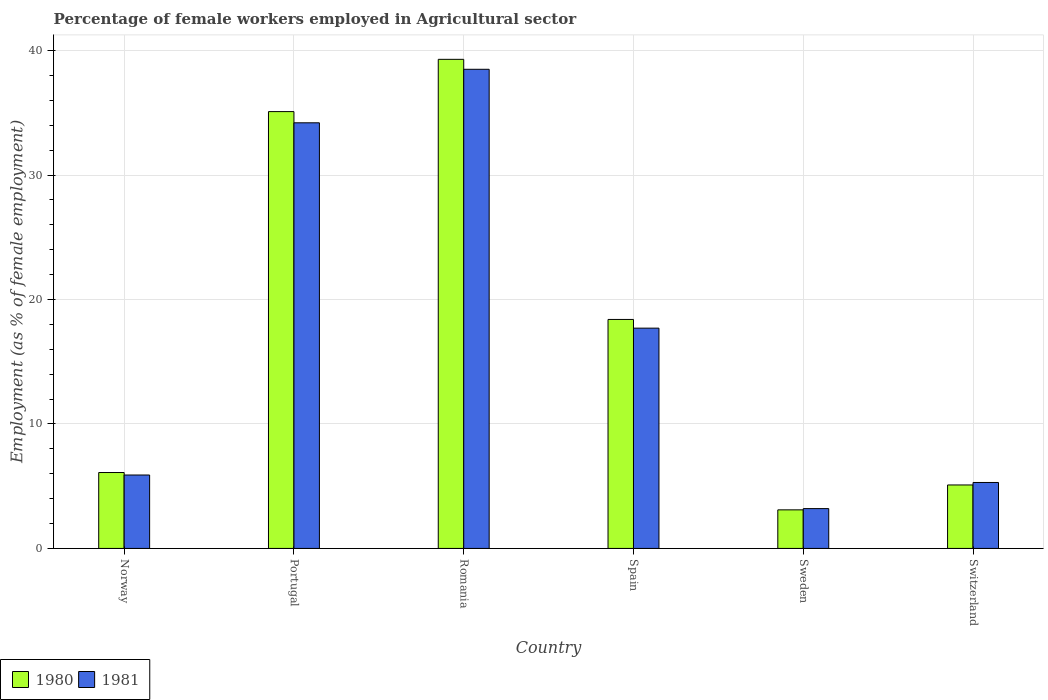How many groups of bars are there?
Make the answer very short. 6. How many bars are there on the 5th tick from the left?
Your response must be concise. 2. How many bars are there on the 6th tick from the right?
Give a very brief answer. 2. What is the label of the 5th group of bars from the left?
Offer a very short reply. Sweden. What is the percentage of females employed in Agricultural sector in 1981 in Spain?
Offer a very short reply. 17.7. Across all countries, what is the maximum percentage of females employed in Agricultural sector in 1981?
Keep it short and to the point. 38.5. Across all countries, what is the minimum percentage of females employed in Agricultural sector in 1980?
Offer a terse response. 3.1. In which country was the percentage of females employed in Agricultural sector in 1980 maximum?
Offer a terse response. Romania. What is the total percentage of females employed in Agricultural sector in 1980 in the graph?
Offer a very short reply. 107.1. What is the difference between the percentage of females employed in Agricultural sector in 1980 in Portugal and that in Sweden?
Keep it short and to the point. 32. What is the difference between the percentage of females employed in Agricultural sector in 1981 in Portugal and the percentage of females employed in Agricultural sector in 1980 in Romania?
Your answer should be very brief. -5.1. What is the average percentage of females employed in Agricultural sector in 1981 per country?
Offer a terse response. 17.47. What is the difference between the percentage of females employed in Agricultural sector of/in 1980 and percentage of females employed in Agricultural sector of/in 1981 in Romania?
Offer a very short reply. 0.8. In how many countries, is the percentage of females employed in Agricultural sector in 1980 greater than 24 %?
Your answer should be compact. 2. What is the ratio of the percentage of females employed in Agricultural sector in 1981 in Portugal to that in Switzerland?
Your response must be concise. 6.45. Is the percentage of females employed in Agricultural sector in 1981 in Romania less than that in Spain?
Your answer should be compact. No. Is the difference between the percentage of females employed in Agricultural sector in 1980 in Norway and Romania greater than the difference between the percentage of females employed in Agricultural sector in 1981 in Norway and Romania?
Ensure brevity in your answer.  No. What is the difference between the highest and the second highest percentage of females employed in Agricultural sector in 1980?
Offer a very short reply. -16.7. What is the difference between the highest and the lowest percentage of females employed in Agricultural sector in 1981?
Ensure brevity in your answer.  35.3. Is the sum of the percentage of females employed in Agricultural sector in 1981 in Portugal and Sweden greater than the maximum percentage of females employed in Agricultural sector in 1980 across all countries?
Provide a succinct answer. No. Are all the bars in the graph horizontal?
Your response must be concise. No. Are the values on the major ticks of Y-axis written in scientific E-notation?
Keep it short and to the point. No. Does the graph contain grids?
Give a very brief answer. Yes. Where does the legend appear in the graph?
Give a very brief answer. Bottom left. How many legend labels are there?
Make the answer very short. 2. What is the title of the graph?
Give a very brief answer. Percentage of female workers employed in Agricultural sector. Does "2004" appear as one of the legend labels in the graph?
Offer a very short reply. No. What is the label or title of the Y-axis?
Provide a succinct answer. Employment (as % of female employment). What is the Employment (as % of female employment) in 1980 in Norway?
Give a very brief answer. 6.1. What is the Employment (as % of female employment) in 1981 in Norway?
Provide a succinct answer. 5.9. What is the Employment (as % of female employment) of 1980 in Portugal?
Offer a terse response. 35.1. What is the Employment (as % of female employment) in 1981 in Portugal?
Your response must be concise. 34.2. What is the Employment (as % of female employment) in 1980 in Romania?
Ensure brevity in your answer.  39.3. What is the Employment (as % of female employment) in 1981 in Romania?
Give a very brief answer. 38.5. What is the Employment (as % of female employment) in 1980 in Spain?
Your answer should be very brief. 18.4. What is the Employment (as % of female employment) in 1981 in Spain?
Keep it short and to the point. 17.7. What is the Employment (as % of female employment) of 1980 in Sweden?
Offer a very short reply. 3.1. What is the Employment (as % of female employment) in 1981 in Sweden?
Your answer should be very brief. 3.2. What is the Employment (as % of female employment) of 1980 in Switzerland?
Your response must be concise. 5.1. What is the Employment (as % of female employment) of 1981 in Switzerland?
Keep it short and to the point. 5.3. Across all countries, what is the maximum Employment (as % of female employment) in 1980?
Your answer should be compact. 39.3. Across all countries, what is the maximum Employment (as % of female employment) in 1981?
Make the answer very short. 38.5. Across all countries, what is the minimum Employment (as % of female employment) of 1980?
Your answer should be compact. 3.1. Across all countries, what is the minimum Employment (as % of female employment) of 1981?
Your answer should be very brief. 3.2. What is the total Employment (as % of female employment) of 1980 in the graph?
Provide a short and direct response. 107.1. What is the total Employment (as % of female employment) of 1981 in the graph?
Your answer should be compact. 104.8. What is the difference between the Employment (as % of female employment) in 1980 in Norway and that in Portugal?
Your answer should be compact. -29. What is the difference between the Employment (as % of female employment) of 1981 in Norway and that in Portugal?
Your response must be concise. -28.3. What is the difference between the Employment (as % of female employment) of 1980 in Norway and that in Romania?
Offer a very short reply. -33.2. What is the difference between the Employment (as % of female employment) in 1981 in Norway and that in Romania?
Keep it short and to the point. -32.6. What is the difference between the Employment (as % of female employment) in 1980 in Norway and that in Sweden?
Make the answer very short. 3. What is the difference between the Employment (as % of female employment) of 1981 in Norway and that in Sweden?
Your response must be concise. 2.7. What is the difference between the Employment (as % of female employment) of 1981 in Norway and that in Switzerland?
Make the answer very short. 0.6. What is the difference between the Employment (as % of female employment) in 1981 in Portugal and that in Romania?
Ensure brevity in your answer.  -4.3. What is the difference between the Employment (as % of female employment) of 1980 in Portugal and that in Sweden?
Provide a succinct answer. 32. What is the difference between the Employment (as % of female employment) of 1981 in Portugal and that in Switzerland?
Your response must be concise. 28.9. What is the difference between the Employment (as % of female employment) of 1980 in Romania and that in Spain?
Make the answer very short. 20.9. What is the difference between the Employment (as % of female employment) in 1981 in Romania and that in Spain?
Provide a short and direct response. 20.8. What is the difference between the Employment (as % of female employment) of 1980 in Romania and that in Sweden?
Make the answer very short. 36.2. What is the difference between the Employment (as % of female employment) of 1981 in Romania and that in Sweden?
Provide a succinct answer. 35.3. What is the difference between the Employment (as % of female employment) of 1980 in Romania and that in Switzerland?
Provide a succinct answer. 34.2. What is the difference between the Employment (as % of female employment) of 1981 in Romania and that in Switzerland?
Ensure brevity in your answer.  33.2. What is the difference between the Employment (as % of female employment) in 1980 in Spain and that in Sweden?
Offer a very short reply. 15.3. What is the difference between the Employment (as % of female employment) in 1981 in Spain and that in Sweden?
Make the answer very short. 14.5. What is the difference between the Employment (as % of female employment) of 1981 in Sweden and that in Switzerland?
Your answer should be very brief. -2.1. What is the difference between the Employment (as % of female employment) of 1980 in Norway and the Employment (as % of female employment) of 1981 in Portugal?
Provide a succinct answer. -28.1. What is the difference between the Employment (as % of female employment) in 1980 in Norway and the Employment (as % of female employment) in 1981 in Romania?
Make the answer very short. -32.4. What is the difference between the Employment (as % of female employment) of 1980 in Norway and the Employment (as % of female employment) of 1981 in Spain?
Your response must be concise. -11.6. What is the difference between the Employment (as % of female employment) in 1980 in Norway and the Employment (as % of female employment) in 1981 in Sweden?
Your answer should be very brief. 2.9. What is the difference between the Employment (as % of female employment) in 1980 in Norway and the Employment (as % of female employment) in 1981 in Switzerland?
Provide a succinct answer. 0.8. What is the difference between the Employment (as % of female employment) in 1980 in Portugal and the Employment (as % of female employment) in 1981 in Sweden?
Ensure brevity in your answer.  31.9. What is the difference between the Employment (as % of female employment) in 1980 in Portugal and the Employment (as % of female employment) in 1981 in Switzerland?
Offer a terse response. 29.8. What is the difference between the Employment (as % of female employment) in 1980 in Romania and the Employment (as % of female employment) in 1981 in Spain?
Give a very brief answer. 21.6. What is the difference between the Employment (as % of female employment) in 1980 in Romania and the Employment (as % of female employment) in 1981 in Sweden?
Keep it short and to the point. 36.1. What is the difference between the Employment (as % of female employment) in 1980 in Sweden and the Employment (as % of female employment) in 1981 in Switzerland?
Provide a short and direct response. -2.2. What is the average Employment (as % of female employment) of 1980 per country?
Offer a terse response. 17.85. What is the average Employment (as % of female employment) in 1981 per country?
Keep it short and to the point. 17.47. What is the difference between the Employment (as % of female employment) in 1980 and Employment (as % of female employment) in 1981 in Norway?
Make the answer very short. 0.2. What is the difference between the Employment (as % of female employment) of 1980 and Employment (as % of female employment) of 1981 in Romania?
Give a very brief answer. 0.8. What is the difference between the Employment (as % of female employment) of 1980 and Employment (as % of female employment) of 1981 in Sweden?
Offer a very short reply. -0.1. What is the ratio of the Employment (as % of female employment) of 1980 in Norway to that in Portugal?
Keep it short and to the point. 0.17. What is the ratio of the Employment (as % of female employment) in 1981 in Norway to that in Portugal?
Make the answer very short. 0.17. What is the ratio of the Employment (as % of female employment) in 1980 in Norway to that in Romania?
Offer a very short reply. 0.16. What is the ratio of the Employment (as % of female employment) of 1981 in Norway to that in Romania?
Provide a succinct answer. 0.15. What is the ratio of the Employment (as % of female employment) in 1980 in Norway to that in Spain?
Your answer should be compact. 0.33. What is the ratio of the Employment (as % of female employment) in 1980 in Norway to that in Sweden?
Provide a short and direct response. 1.97. What is the ratio of the Employment (as % of female employment) in 1981 in Norway to that in Sweden?
Offer a very short reply. 1.84. What is the ratio of the Employment (as % of female employment) of 1980 in Norway to that in Switzerland?
Give a very brief answer. 1.2. What is the ratio of the Employment (as % of female employment) of 1981 in Norway to that in Switzerland?
Provide a short and direct response. 1.11. What is the ratio of the Employment (as % of female employment) in 1980 in Portugal to that in Romania?
Your response must be concise. 0.89. What is the ratio of the Employment (as % of female employment) of 1981 in Portugal to that in Romania?
Offer a very short reply. 0.89. What is the ratio of the Employment (as % of female employment) in 1980 in Portugal to that in Spain?
Your answer should be very brief. 1.91. What is the ratio of the Employment (as % of female employment) in 1981 in Portugal to that in Spain?
Your response must be concise. 1.93. What is the ratio of the Employment (as % of female employment) of 1980 in Portugal to that in Sweden?
Give a very brief answer. 11.32. What is the ratio of the Employment (as % of female employment) of 1981 in Portugal to that in Sweden?
Your response must be concise. 10.69. What is the ratio of the Employment (as % of female employment) of 1980 in Portugal to that in Switzerland?
Offer a very short reply. 6.88. What is the ratio of the Employment (as % of female employment) of 1981 in Portugal to that in Switzerland?
Give a very brief answer. 6.45. What is the ratio of the Employment (as % of female employment) of 1980 in Romania to that in Spain?
Keep it short and to the point. 2.14. What is the ratio of the Employment (as % of female employment) in 1981 in Romania to that in Spain?
Your answer should be very brief. 2.18. What is the ratio of the Employment (as % of female employment) in 1980 in Romania to that in Sweden?
Your response must be concise. 12.68. What is the ratio of the Employment (as % of female employment) of 1981 in Romania to that in Sweden?
Give a very brief answer. 12.03. What is the ratio of the Employment (as % of female employment) in 1980 in Romania to that in Switzerland?
Your response must be concise. 7.71. What is the ratio of the Employment (as % of female employment) in 1981 in Romania to that in Switzerland?
Make the answer very short. 7.26. What is the ratio of the Employment (as % of female employment) of 1980 in Spain to that in Sweden?
Make the answer very short. 5.94. What is the ratio of the Employment (as % of female employment) in 1981 in Spain to that in Sweden?
Your answer should be very brief. 5.53. What is the ratio of the Employment (as % of female employment) in 1980 in Spain to that in Switzerland?
Offer a very short reply. 3.61. What is the ratio of the Employment (as % of female employment) in 1981 in Spain to that in Switzerland?
Your answer should be compact. 3.34. What is the ratio of the Employment (as % of female employment) in 1980 in Sweden to that in Switzerland?
Your answer should be very brief. 0.61. What is the ratio of the Employment (as % of female employment) of 1981 in Sweden to that in Switzerland?
Your answer should be very brief. 0.6. What is the difference between the highest and the lowest Employment (as % of female employment) of 1980?
Ensure brevity in your answer.  36.2. What is the difference between the highest and the lowest Employment (as % of female employment) of 1981?
Your answer should be very brief. 35.3. 